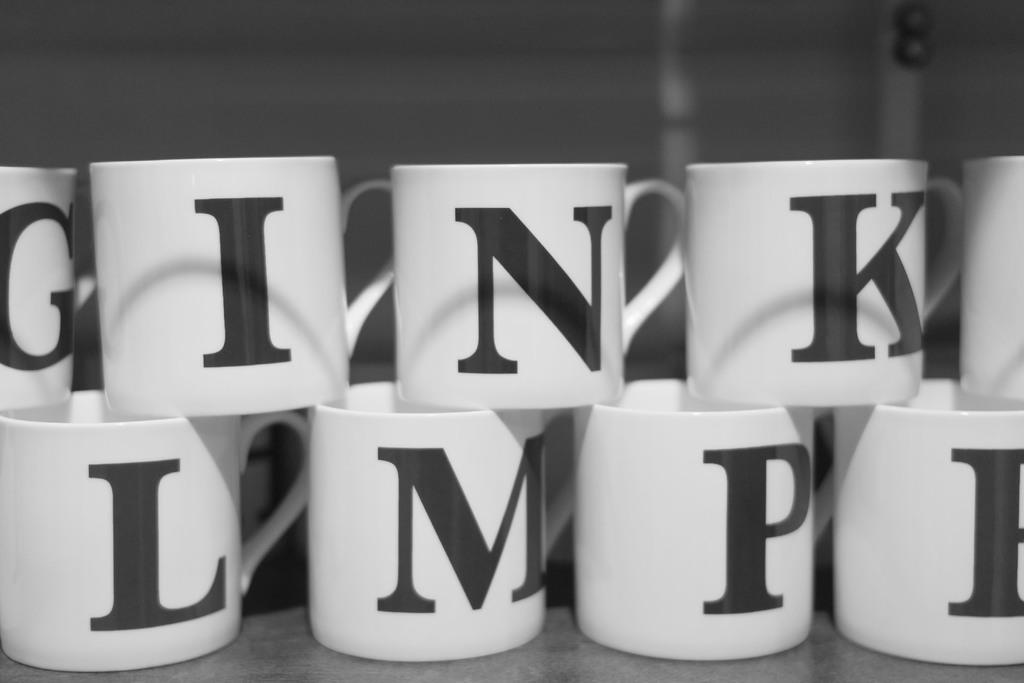<image>
Describe the image concisely. Many white cups on top of one another with one having the letter "K" on it. 